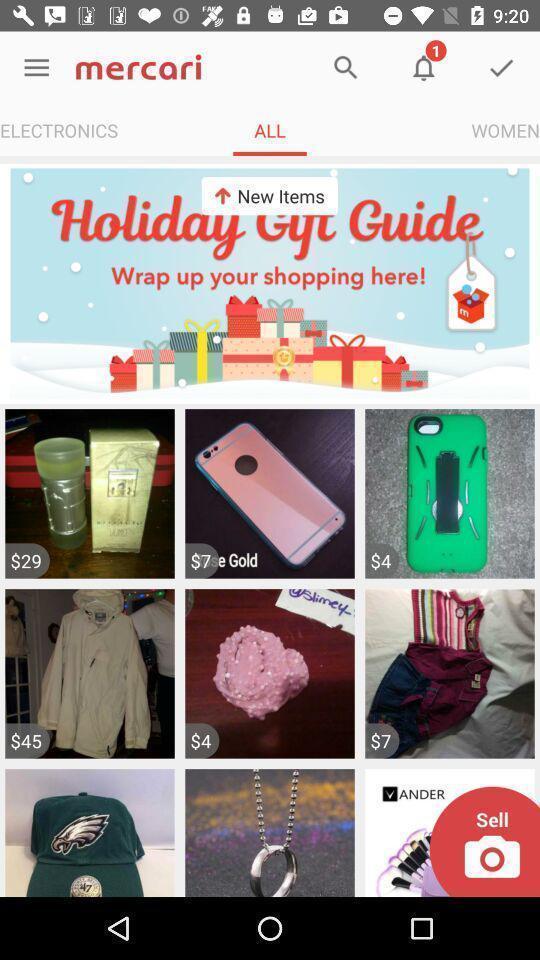What is the overall content of this screenshot? Various items in an online shopping app. 